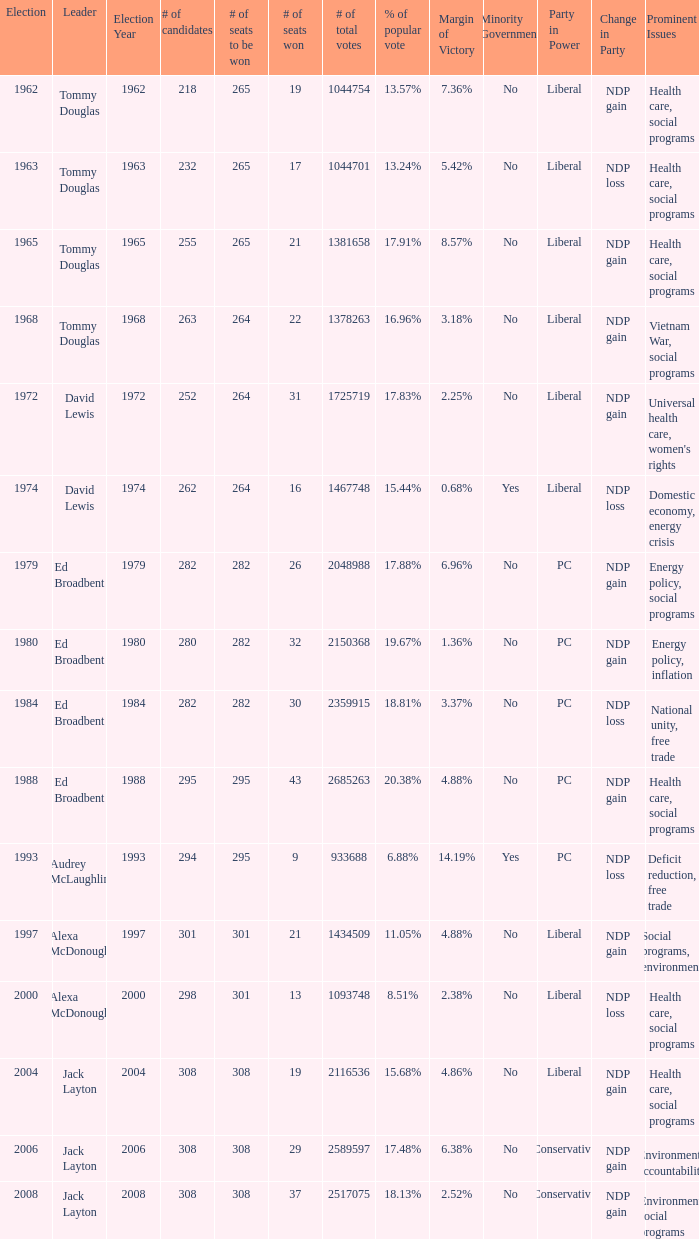Name the number of seats to be won being % of popular vote at 6.88% 295.0. 